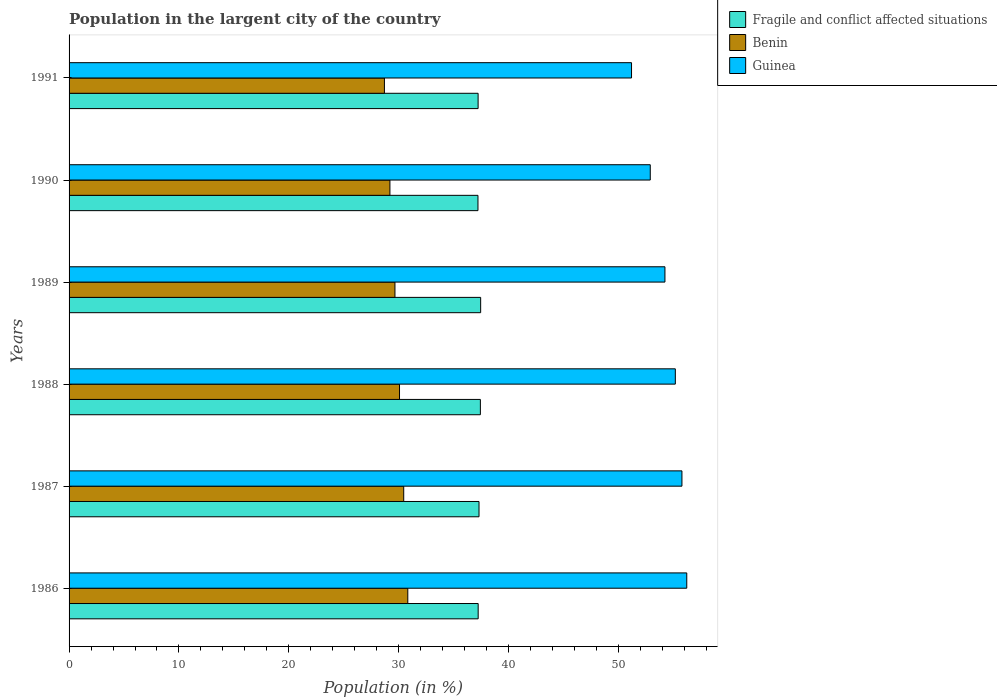How many different coloured bars are there?
Keep it short and to the point. 3. How many bars are there on the 4th tick from the top?
Offer a terse response. 3. How many bars are there on the 2nd tick from the bottom?
Make the answer very short. 3. What is the percentage of population in the largent city in Fragile and conflict affected situations in 1989?
Offer a very short reply. 37.46. Across all years, what is the maximum percentage of population in the largent city in Fragile and conflict affected situations?
Provide a succinct answer. 37.46. Across all years, what is the minimum percentage of population in the largent city in Fragile and conflict affected situations?
Provide a succinct answer. 37.21. What is the total percentage of population in the largent city in Benin in the graph?
Offer a very short reply. 178.92. What is the difference between the percentage of population in the largent city in Benin in 1987 and that in 1991?
Make the answer very short. 1.76. What is the difference between the percentage of population in the largent city in Guinea in 1991 and the percentage of population in the largent city in Benin in 1989?
Give a very brief answer. 21.53. What is the average percentage of population in the largent city in Fragile and conflict affected situations per year?
Your response must be concise. 37.31. In the year 1991, what is the difference between the percentage of population in the largent city in Guinea and percentage of population in the largent city in Benin?
Your answer should be very brief. 22.49. What is the ratio of the percentage of population in the largent city in Fragile and conflict affected situations in 1986 to that in 1991?
Keep it short and to the point. 1. What is the difference between the highest and the second highest percentage of population in the largent city in Benin?
Offer a terse response. 0.37. What is the difference between the highest and the lowest percentage of population in the largent city in Benin?
Provide a succinct answer. 2.13. In how many years, is the percentage of population in the largent city in Fragile and conflict affected situations greater than the average percentage of population in the largent city in Fragile and conflict affected situations taken over all years?
Give a very brief answer. 2. What does the 1st bar from the top in 1987 represents?
Make the answer very short. Guinea. What does the 3rd bar from the bottom in 1990 represents?
Offer a very short reply. Guinea. How many bars are there?
Provide a short and direct response. 18. What is the difference between two consecutive major ticks on the X-axis?
Offer a very short reply. 10. Are the values on the major ticks of X-axis written in scientific E-notation?
Provide a short and direct response. No. What is the title of the graph?
Offer a very short reply. Population in the largent city of the country. Does "South Africa" appear as one of the legend labels in the graph?
Give a very brief answer. No. What is the label or title of the Y-axis?
Make the answer very short. Years. What is the Population (in %) in Fragile and conflict affected situations in 1986?
Give a very brief answer. 37.23. What is the Population (in %) of Benin in 1986?
Your response must be concise. 30.83. What is the Population (in %) of Guinea in 1986?
Give a very brief answer. 56.22. What is the Population (in %) in Fragile and conflict affected situations in 1987?
Offer a very short reply. 37.31. What is the Population (in %) of Benin in 1987?
Ensure brevity in your answer.  30.46. What is the Population (in %) of Guinea in 1987?
Provide a short and direct response. 55.78. What is the Population (in %) in Fragile and conflict affected situations in 1988?
Make the answer very short. 37.43. What is the Population (in %) in Benin in 1988?
Keep it short and to the point. 30.08. What is the Population (in %) of Guinea in 1988?
Offer a terse response. 55.18. What is the Population (in %) of Fragile and conflict affected situations in 1989?
Keep it short and to the point. 37.46. What is the Population (in %) of Benin in 1989?
Offer a very short reply. 29.66. What is the Population (in %) in Guinea in 1989?
Ensure brevity in your answer.  54.23. What is the Population (in %) of Fragile and conflict affected situations in 1990?
Provide a succinct answer. 37.21. What is the Population (in %) of Benin in 1990?
Give a very brief answer. 29.2. What is the Population (in %) of Guinea in 1990?
Provide a succinct answer. 52.9. What is the Population (in %) of Fragile and conflict affected situations in 1991?
Give a very brief answer. 37.23. What is the Population (in %) in Benin in 1991?
Provide a short and direct response. 28.7. What is the Population (in %) in Guinea in 1991?
Make the answer very short. 51.19. Across all years, what is the maximum Population (in %) of Fragile and conflict affected situations?
Your answer should be very brief. 37.46. Across all years, what is the maximum Population (in %) of Benin?
Your response must be concise. 30.83. Across all years, what is the maximum Population (in %) of Guinea?
Your response must be concise. 56.22. Across all years, what is the minimum Population (in %) of Fragile and conflict affected situations?
Make the answer very short. 37.21. Across all years, what is the minimum Population (in %) in Benin?
Give a very brief answer. 28.7. Across all years, what is the minimum Population (in %) in Guinea?
Your answer should be very brief. 51.19. What is the total Population (in %) of Fragile and conflict affected situations in the graph?
Your response must be concise. 223.88. What is the total Population (in %) of Benin in the graph?
Offer a very short reply. 178.92. What is the total Population (in %) of Guinea in the graph?
Your answer should be very brief. 325.5. What is the difference between the Population (in %) of Fragile and conflict affected situations in 1986 and that in 1987?
Keep it short and to the point. -0.08. What is the difference between the Population (in %) of Benin in 1986 and that in 1987?
Keep it short and to the point. 0.37. What is the difference between the Population (in %) in Guinea in 1986 and that in 1987?
Ensure brevity in your answer.  0.44. What is the difference between the Population (in %) of Fragile and conflict affected situations in 1986 and that in 1988?
Your answer should be very brief. -0.2. What is the difference between the Population (in %) in Benin in 1986 and that in 1988?
Offer a very short reply. 0.75. What is the difference between the Population (in %) in Guinea in 1986 and that in 1988?
Provide a succinct answer. 1.04. What is the difference between the Population (in %) in Fragile and conflict affected situations in 1986 and that in 1989?
Offer a very short reply. -0.23. What is the difference between the Population (in %) in Benin in 1986 and that in 1989?
Offer a terse response. 1.17. What is the difference between the Population (in %) in Guinea in 1986 and that in 1989?
Offer a terse response. 1.99. What is the difference between the Population (in %) in Fragile and conflict affected situations in 1986 and that in 1990?
Offer a terse response. 0.02. What is the difference between the Population (in %) of Benin in 1986 and that in 1990?
Offer a terse response. 1.63. What is the difference between the Population (in %) of Guinea in 1986 and that in 1990?
Ensure brevity in your answer.  3.32. What is the difference between the Population (in %) in Fragile and conflict affected situations in 1986 and that in 1991?
Offer a very short reply. 0.01. What is the difference between the Population (in %) in Benin in 1986 and that in 1991?
Keep it short and to the point. 2.13. What is the difference between the Population (in %) in Guinea in 1986 and that in 1991?
Give a very brief answer. 5.03. What is the difference between the Population (in %) in Fragile and conflict affected situations in 1987 and that in 1988?
Your response must be concise. -0.12. What is the difference between the Population (in %) in Benin in 1987 and that in 1988?
Give a very brief answer. 0.38. What is the difference between the Population (in %) in Guinea in 1987 and that in 1988?
Make the answer very short. 0.6. What is the difference between the Population (in %) of Fragile and conflict affected situations in 1987 and that in 1989?
Provide a short and direct response. -0.15. What is the difference between the Population (in %) in Benin in 1987 and that in 1989?
Provide a short and direct response. 0.8. What is the difference between the Population (in %) in Guinea in 1987 and that in 1989?
Give a very brief answer. 1.55. What is the difference between the Population (in %) in Fragile and conflict affected situations in 1987 and that in 1990?
Your answer should be very brief. 0.1. What is the difference between the Population (in %) in Benin in 1987 and that in 1990?
Keep it short and to the point. 1.26. What is the difference between the Population (in %) in Guinea in 1987 and that in 1990?
Offer a very short reply. 2.88. What is the difference between the Population (in %) in Fragile and conflict affected situations in 1987 and that in 1991?
Your answer should be very brief. 0.08. What is the difference between the Population (in %) in Benin in 1987 and that in 1991?
Your answer should be very brief. 1.76. What is the difference between the Population (in %) in Guinea in 1987 and that in 1991?
Your answer should be very brief. 4.59. What is the difference between the Population (in %) in Fragile and conflict affected situations in 1988 and that in 1989?
Keep it short and to the point. -0.03. What is the difference between the Population (in %) in Benin in 1988 and that in 1989?
Your response must be concise. 0.42. What is the difference between the Population (in %) in Guinea in 1988 and that in 1989?
Offer a very short reply. 0.94. What is the difference between the Population (in %) in Fragile and conflict affected situations in 1988 and that in 1990?
Make the answer very short. 0.22. What is the difference between the Population (in %) of Benin in 1988 and that in 1990?
Provide a succinct answer. 0.87. What is the difference between the Population (in %) of Guinea in 1988 and that in 1990?
Your answer should be very brief. 2.28. What is the difference between the Population (in %) in Fragile and conflict affected situations in 1988 and that in 1991?
Your answer should be compact. 0.21. What is the difference between the Population (in %) in Benin in 1988 and that in 1991?
Your answer should be compact. 1.37. What is the difference between the Population (in %) in Guinea in 1988 and that in 1991?
Provide a short and direct response. 3.99. What is the difference between the Population (in %) of Fragile and conflict affected situations in 1989 and that in 1990?
Offer a very short reply. 0.25. What is the difference between the Population (in %) of Benin in 1989 and that in 1990?
Ensure brevity in your answer.  0.46. What is the difference between the Population (in %) of Guinea in 1989 and that in 1990?
Provide a short and direct response. 1.34. What is the difference between the Population (in %) in Fragile and conflict affected situations in 1989 and that in 1991?
Your answer should be very brief. 0.23. What is the difference between the Population (in %) in Benin in 1989 and that in 1991?
Ensure brevity in your answer.  0.96. What is the difference between the Population (in %) in Guinea in 1989 and that in 1991?
Offer a terse response. 3.04. What is the difference between the Population (in %) in Fragile and conflict affected situations in 1990 and that in 1991?
Ensure brevity in your answer.  -0.01. What is the difference between the Population (in %) in Benin in 1990 and that in 1991?
Ensure brevity in your answer.  0.5. What is the difference between the Population (in %) of Guinea in 1990 and that in 1991?
Provide a short and direct response. 1.71. What is the difference between the Population (in %) of Fragile and conflict affected situations in 1986 and the Population (in %) of Benin in 1987?
Your answer should be compact. 6.78. What is the difference between the Population (in %) of Fragile and conflict affected situations in 1986 and the Population (in %) of Guinea in 1987?
Give a very brief answer. -18.55. What is the difference between the Population (in %) of Benin in 1986 and the Population (in %) of Guinea in 1987?
Make the answer very short. -24.95. What is the difference between the Population (in %) of Fragile and conflict affected situations in 1986 and the Population (in %) of Benin in 1988?
Offer a terse response. 7.16. What is the difference between the Population (in %) in Fragile and conflict affected situations in 1986 and the Population (in %) in Guinea in 1988?
Make the answer very short. -17.94. What is the difference between the Population (in %) in Benin in 1986 and the Population (in %) in Guinea in 1988?
Provide a succinct answer. -24.35. What is the difference between the Population (in %) of Fragile and conflict affected situations in 1986 and the Population (in %) of Benin in 1989?
Your answer should be very brief. 7.57. What is the difference between the Population (in %) in Fragile and conflict affected situations in 1986 and the Population (in %) in Guinea in 1989?
Ensure brevity in your answer.  -17. What is the difference between the Population (in %) of Benin in 1986 and the Population (in %) of Guinea in 1989?
Your response must be concise. -23.4. What is the difference between the Population (in %) of Fragile and conflict affected situations in 1986 and the Population (in %) of Benin in 1990?
Give a very brief answer. 8.03. What is the difference between the Population (in %) in Fragile and conflict affected situations in 1986 and the Population (in %) in Guinea in 1990?
Give a very brief answer. -15.66. What is the difference between the Population (in %) of Benin in 1986 and the Population (in %) of Guinea in 1990?
Offer a terse response. -22.07. What is the difference between the Population (in %) in Fragile and conflict affected situations in 1986 and the Population (in %) in Benin in 1991?
Your answer should be compact. 8.53. What is the difference between the Population (in %) in Fragile and conflict affected situations in 1986 and the Population (in %) in Guinea in 1991?
Provide a succinct answer. -13.96. What is the difference between the Population (in %) of Benin in 1986 and the Population (in %) of Guinea in 1991?
Your answer should be very brief. -20.36. What is the difference between the Population (in %) in Fragile and conflict affected situations in 1987 and the Population (in %) in Benin in 1988?
Provide a short and direct response. 7.24. What is the difference between the Population (in %) of Fragile and conflict affected situations in 1987 and the Population (in %) of Guinea in 1988?
Ensure brevity in your answer.  -17.87. What is the difference between the Population (in %) in Benin in 1987 and the Population (in %) in Guinea in 1988?
Offer a terse response. -24.72. What is the difference between the Population (in %) in Fragile and conflict affected situations in 1987 and the Population (in %) in Benin in 1989?
Provide a short and direct response. 7.65. What is the difference between the Population (in %) of Fragile and conflict affected situations in 1987 and the Population (in %) of Guinea in 1989?
Ensure brevity in your answer.  -16.92. What is the difference between the Population (in %) in Benin in 1987 and the Population (in %) in Guinea in 1989?
Give a very brief answer. -23.78. What is the difference between the Population (in %) in Fragile and conflict affected situations in 1987 and the Population (in %) in Benin in 1990?
Ensure brevity in your answer.  8.11. What is the difference between the Population (in %) of Fragile and conflict affected situations in 1987 and the Population (in %) of Guinea in 1990?
Provide a short and direct response. -15.59. What is the difference between the Population (in %) in Benin in 1987 and the Population (in %) in Guinea in 1990?
Ensure brevity in your answer.  -22.44. What is the difference between the Population (in %) of Fragile and conflict affected situations in 1987 and the Population (in %) of Benin in 1991?
Provide a short and direct response. 8.61. What is the difference between the Population (in %) in Fragile and conflict affected situations in 1987 and the Population (in %) in Guinea in 1991?
Give a very brief answer. -13.88. What is the difference between the Population (in %) of Benin in 1987 and the Population (in %) of Guinea in 1991?
Provide a succinct answer. -20.73. What is the difference between the Population (in %) in Fragile and conflict affected situations in 1988 and the Population (in %) in Benin in 1989?
Ensure brevity in your answer.  7.78. What is the difference between the Population (in %) of Fragile and conflict affected situations in 1988 and the Population (in %) of Guinea in 1989?
Provide a short and direct response. -16.8. What is the difference between the Population (in %) in Benin in 1988 and the Population (in %) in Guinea in 1989?
Give a very brief answer. -24.16. What is the difference between the Population (in %) of Fragile and conflict affected situations in 1988 and the Population (in %) of Benin in 1990?
Your response must be concise. 8.23. What is the difference between the Population (in %) in Fragile and conflict affected situations in 1988 and the Population (in %) in Guinea in 1990?
Keep it short and to the point. -15.46. What is the difference between the Population (in %) in Benin in 1988 and the Population (in %) in Guinea in 1990?
Ensure brevity in your answer.  -22.82. What is the difference between the Population (in %) in Fragile and conflict affected situations in 1988 and the Population (in %) in Benin in 1991?
Ensure brevity in your answer.  8.73. What is the difference between the Population (in %) in Fragile and conflict affected situations in 1988 and the Population (in %) in Guinea in 1991?
Ensure brevity in your answer.  -13.76. What is the difference between the Population (in %) in Benin in 1988 and the Population (in %) in Guinea in 1991?
Your answer should be very brief. -21.12. What is the difference between the Population (in %) of Fragile and conflict affected situations in 1989 and the Population (in %) of Benin in 1990?
Your answer should be compact. 8.26. What is the difference between the Population (in %) in Fragile and conflict affected situations in 1989 and the Population (in %) in Guinea in 1990?
Give a very brief answer. -15.44. What is the difference between the Population (in %) in Benin in 1989 and the Population (in %) in Guinea in 1990?
Keep it short and to the point. -23.24. What is the difference between the Population (in %) of Fragile and conflict affected situations in 1989 and the Population (in %) of Benin in 1991?
Your response must be concise. 8.76. What is the difference between the Population (in %) of Fragile and conflict affected situations in 1989 and the Population (in %) of Guinea in 1991?
Ensure brevity in your answer.  -13.73. What is the difference between the Population (in %) in Benin in 1989 and the Population (in %) in Guinea in 1991?
Your response must be concise. -21.53. What is the difference between the Population (in %) in Fragile and conflict affected situations in 1990 and the Population (in %) in Benin in 1991?
Offer a terse response. 8.51. What is the difference between the Population (in %) of Fragile and conflict affected situations in 1990 and the Population (in %) of Guinea in 1991?
Ensure brevity in your answer.  -13.98. What is the difference between the Population (in %) of Benin in 1990 and the Population (in %) of Guinea in 1991?
Give a very brief answer. -21.99. What is the average Population (in %) of Fragile and conflict affected situations per year?
Offer a very short reply. 37.31. What is the average Population (in %) of Benin per year?
Provide a succinct answer. 29.82. What is the average Population (in %) in Guinea per year?
Offer a very short reply. 54.25. In the year 1986, what is the difference between the Population (in %) of Fragile and conflict affected situations and Population (in %) of Benin?
Offer a very short reply. 6.41. In the year 1986, what is the difference between the Population (in %) in Fragile and conflict affected situations and Population (in %) in Guinea?
Offer a terse response. -18.98. In the year 1986, what is the difference between the Population (in %) in Benin and Population (in %) in Guinea?
Give a very brief answer. -25.39. In the year 1987, what is the difference between the Population (in %) in Fragile and conflict affected situations and Population (in %) in Benin?
Give a very brief answer. 6.85. In the year 1987, what is the difference between the Population (in %) in Fragile and conflict affected situations and Population (in %) in Guinea?
Your answer should be compact. -18.47. In the year 1987, what is the difference between the Population (in %) of Benin and Population (in %) of Guinea?
Ensure brevity in your answer.  -25.32. In the year 1988, what is the difference between the Population (in %) in Fragile and conflict affected situations and Population (in %) in Benin?
Keep it short and to the point. 7.36. In the year 1988, what is the difference between the Population (in %) in Fragile and conflict affected situations and Population (in %) in Guinea?
Provide a short and direct response. -17.74. In the year 1988, what is the difference between the Population (in %) of Benin and Population (in %) of Guinea?
Keep it short and to the point. -25.1. In the year 1989, what is the difference between the Population (in %) in Fragile and conflict affected situations and Population (in %) in Benin?
Your response must be concise. 7.8. In the year 1989, what is the difference between the Population (in %) of Fragile and conflict affected situations and Population (in %) of Guinea?
Your answer should be compact. -16.77. In the year 1989, what is the difference between the Population (in %) in Benin and Population (in %) in Guinea?
Keep it short and to the point. -24.57. In the year 1990, what is the difference between the Population (in %) of Fragile and conflict affected situations and Population (in %) of Benin?
Your response must be concise. 8.01. In the year 1990, what is the difference between the Population (in %) in Fragile and conflict affected situations and Population (in %) in Guinea?
Provide a succinct answer. -15.68. In the year 1990, what is the difference between the Population (in %) in Benin and Population (in %) in Guinea?
Make the answer very short. -23.7. In the year 1991, what is the difference between the Population (in %) of Fragile and conflict affected situations and Population (in %) of Benin?
Ensure brevity in your answer.  8.53. In the year 1991, what is the difference between the Population (in %) of Fragile and conflict affected situations and Population (in %) of Guinea?
Your response must be concise. -13.96. In the year 1991, what is the difference between the Population (in %) of Benin and Population (in %) of Guinea?
Offer a terse response. -22.49. What is the ratio of the Population (in %) in Benin in 1986 to that in 1987?
Ensure brevity in your answer.  1.01. What is the ratio of the Population (in %) of Guinea in 1986 to that in 1987?
Your answer should be very brief. 1.01. What is the ratio of the Population (in %) of Guinea in 1986 to that in 1988?
Offer a terse response. 1.02. What is the ratio of the Population (in %) in Fragile and conflict affected situations in 1986 to that in 1989?
Offer a very short reply. 0.99. What is the ratio of the Population (in %) of Benin in 1986 to that in 1989?
Keep it short and to the point. 1.04. What is the ratio of the Population (in %) of Guinea in 1986 to that in 1989?
Your answer should be compact. 1.04. What is the ratio of the Population (in %) in Fragile and conflict affected situations in 1986 to that in 1990?
Your answer should be very brief. 1. What is the ratio of the Population (in %) of Benin in 1986 to that in 1990?
Ensure brevity in your answer.  1.06. What is the ratio of the Population (in %) of Guinea in 1986 to that in 1990?
Make the answer very short. 1.06. What is the ratio of the Population (in %) of Benin in 1986 to that in 1991?
Keep it short and to the point. 1.07. What is the ratio of the Population (in %) of Guinea in 1986 to that in 1991?
Make the answer very short. 1.1. What is the ratio of the Population (in %) of Benin in 1987 to that in 1988?
Your response must be concise. 1.01. What is the ratio of the Population (in %) in Guinea in 1987 to that in 1988?
Provide a short and direct response. 1.01. What is the ratio of the Population (in %) of Benin in 1987 to that in 1989?
Your answer should be compact. 1.03. What is the ratio of the Population (in %) in Guinea in 1987 to that in 1989?
Offer a terse response. 1.03. What is the ratio of the Population (in %) of Fragile and conflict affected situations in 1987 to that in 1990?
Your response must be concise. 1. What is the ratio of the Population (in %) in Benin in 1987 to that in 1990?
Your response must be concise. 1.04. What is the ratio of the Population (in %) of Guinea in 1987 to that in 1990?
Your answer should be compact. 1.05. What is the ratio of the Population (in %) in Benin in 1987 to that in 1991?
Give a very brief answer. 1.06. What is the ratio of the Population (in %) of Guinea in 1987 to that in 1991?
Your answer should be compact. 1.09. What is the ratio of the Population (in %) of Fragile and conflict affected situations in 1988 to that in 1989?
Give a very brief answer. 1. What is the ratio of the Population (in %) of Guinea in 1988 to that in 1989?
Make the answer very short. 1.02. What is the ratio of the Population (in %) of Fragile and conflict affected situations in 1988 to that in 1990?
Offer a terse response. 1.01. What is the ratio of the Population (in %) of Benin in 1988 to that in 1990?
Give a very brief answer. 1.03. What is the ratio of the Population (in %) of Guinea in 1988 to that in 1990?
Your answer should be very brief. 1.04. What is the ratio of the Population (in %) of Fragile and conflict affected situations in 1988 to that in 1991?
Provide a succinct answer. 1.01. What is the ratio of the Population (in %) in Benin in 1988 to that in 1991?
Offer a terse response. 1.05. What is the ratio of the Population (in %) in Guinea in 1988 to that in 1991?
Provide a succinct answer. 1.08. What is the ratio of the Population (in %) of Fragile and conflict affected situations in 1989 to that in 1990?
Ensure brevity in your answer.  1.01. What is the ratio of the Population (in %) of Benin in 1989 to that in 1990?
Offer a very short reply. 1.02. What is the ratio of the Population (in %) in Guinea in 1989 to that in 1990?
Make the answer very short. 1.03. What is the ratio of the Population (in %) in Fragile and conflict affected situations in 1989 to that in 1991?
Provide a short and direct response. 1.01. What is the ratio of the Population (in %) of Benin in 1989 to that in 1991?
Make the answer very short. 1.03. What is the ratio of the Population (in %) of Guinea in 1989 to that in 1991?
Offer a very short reply. 1.06. What is the ratio of the Population (in %) of Fragile and conflict affected situations in 1990 to that in 1991?
Offer a very short reply. 1. What is the ratio of the Population (in %) in Benin in 1990 to that in 1991?
Offer a terse response. 1.02. What is the difference between the highest and the second highest Population (in %) of Fragile and conflict affected situations?
Your answer should be very brief. 0.03. What is the difference between the highest and the second highest Population (in %) in Benin?
Ensure brevity in your answer.  0.37. What is the difference between the highest and the second highest Population (in %) of Guinea?
Keep it short and to the point. 0.44. What is the difference between the highest and the lowest Population (in %) in Fragile and conflict affected situations?
Ensure brevity in your answer.  0.25. What is the difference between the highest and the lowest Population (in %) in Benin?
Offer a very short reply. 2.13. What is the difference between the highest and the lowest Population (in %) of Guinea?
Give a very brief answer. 5.03. 